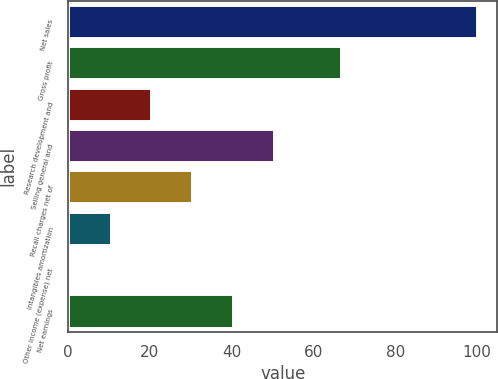<chart> <loc_0><loc_0><loc_500><loc_500><bar_chart><fcel>Net sales<fcel>Gross profit<fcel>Research development and<fcel>Selling general and<fcel>Recall charges net of<fcel>Intangibles amortization<fcel>Other income (expense) net<fcel>Net earnings<nl><fcel>100<fcel>66.7<fcel>20.4<fcel>50.25<fcel>30.35<fcel>10.45<fcel>0.5<fcel>40.3<nl></chart> 